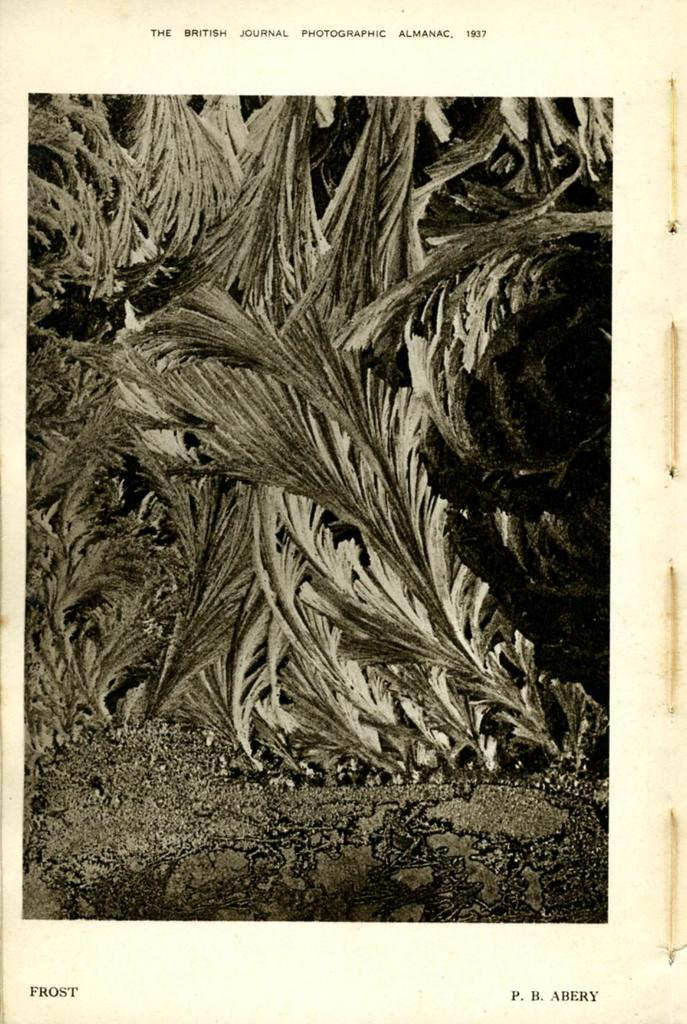What is the main subject of the image within the image? There is an image of a paper in the image. What is depicted within the image on the paper? The paper contains an image of leaves. Where can text be found on the paper? There is text at the top of the paper and text at the bottom of the paper. What industry is the paper used for in the image? There is no indication of the paper's use or the industry it is associated with in the image. 